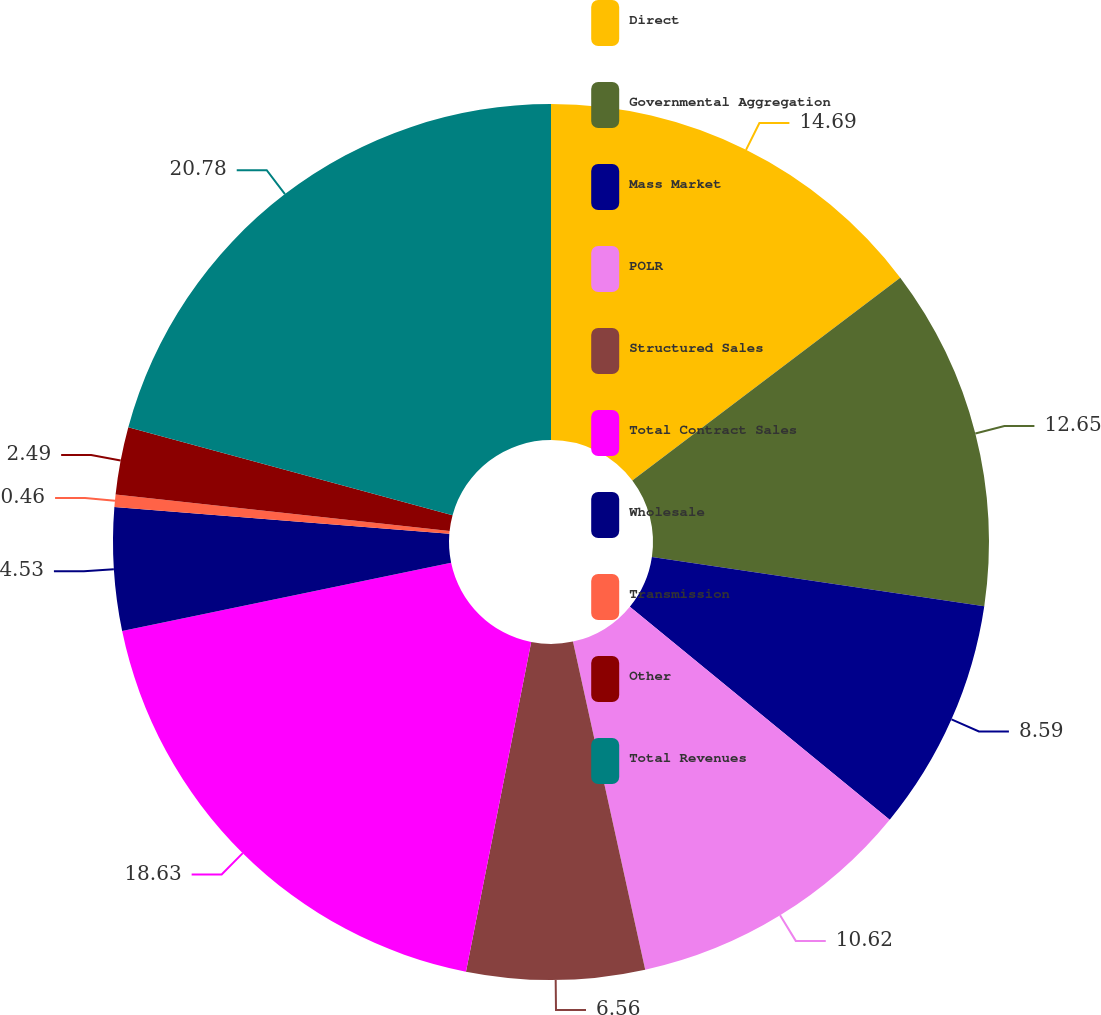Convert chart. <chart><loc_0><loc_0><loc_500><loc_500><pie_chart><fcel>Direct<fcel>Governmental Aggregation<fcel>Mass Market<fcel>POLR<fcel>Structured Sales<fcel>Total Contract Sales<fcel>Wholesale<fcel>Transmission<fcel>Other<fcel>Total Revenues<nl><fcel>14.69%<fcel>12.65%<fcel>8.59%<fcel>10.62%<fcel>6.56%<fcel>18.63%<fcel>4.53%<fcel>0.46%<fcel>2.49%<fcel>20.78%<nl></chart> 